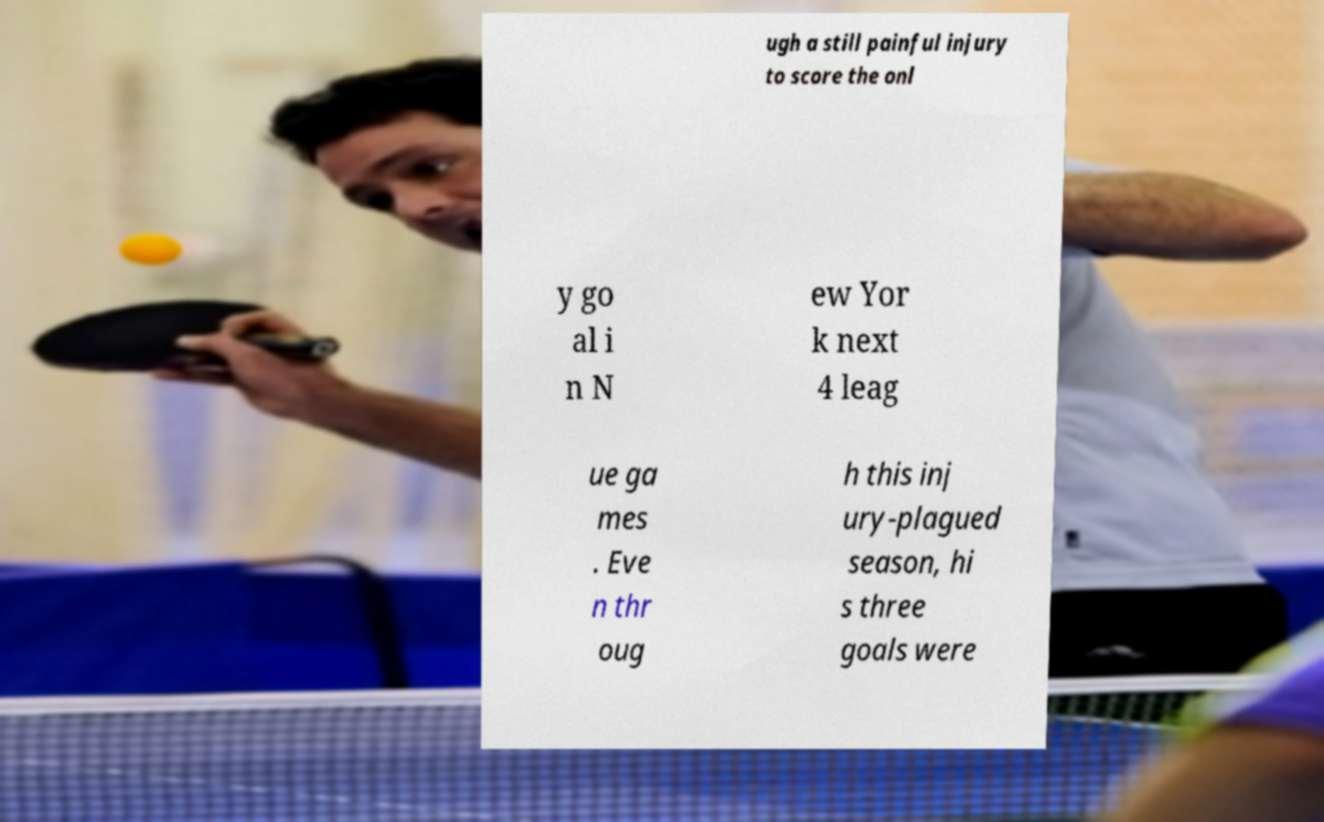Can you accurately transcribe the text from the provided image for me? ugh a still painful injury to score the onl y go al i n N ew Yor k next 4 leag ue ga mes . Eve n thr oug h this inj ury-plagued season, hi s three goals were 